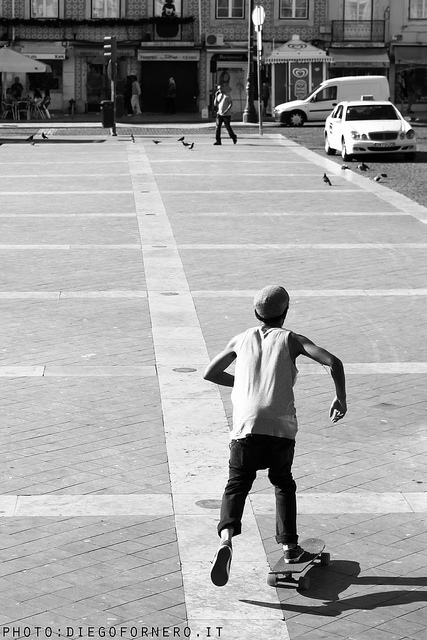Please transcribe the text in this image. PHOTO DIEGOFORNERO IT 